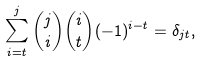<formula> <loc_0><loc_0><loc_500><loc_500>\sum _ { i = t } ^ { j } \binom { j } { i } \binom { i } { t } ( - 1 ) ^ { i - t } = \delta _ { j t } ,</formula> 